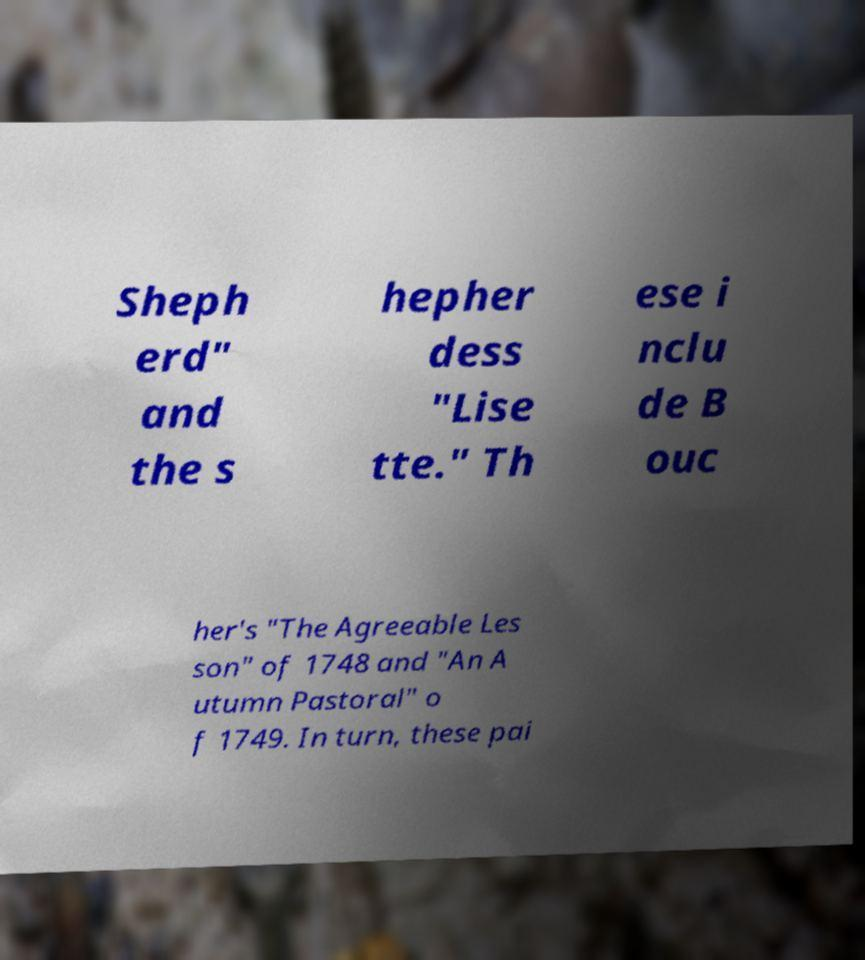For documentation purposes, I need the text within this image transcribed. Could you provide that? Sheph erd" and the s hepher dess "Lise tte." Th ese i nclu de B ouc her's "The Agreeable Les son" of 1748 and "An A utumn Pastoral" o f 1749. In turn, these pai 